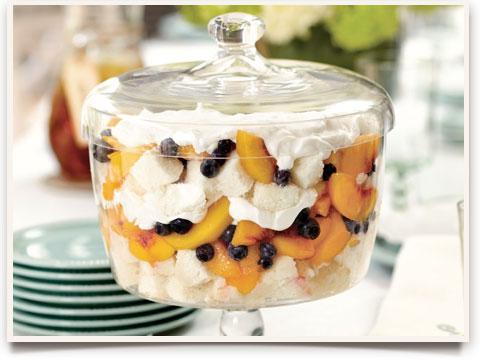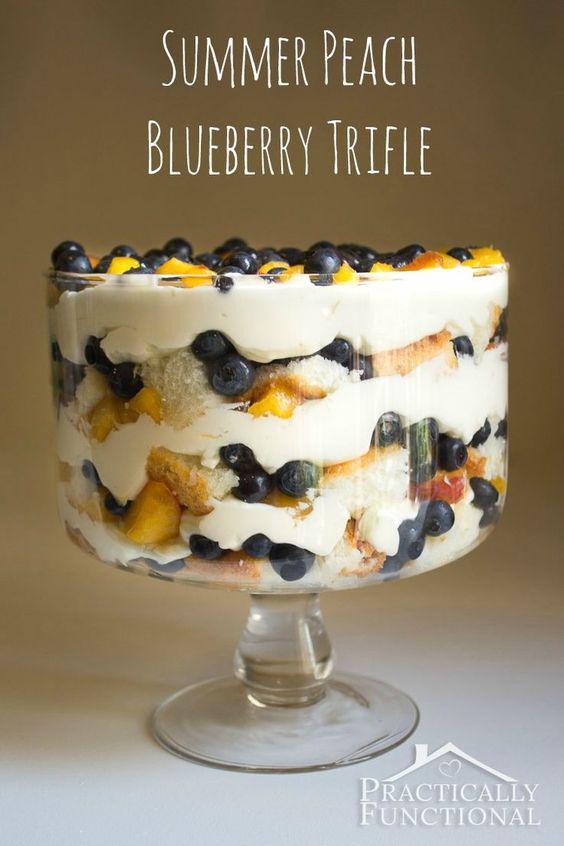The first image is the image on the left, the second image is the image on the right. Assess this claim about the two images: "One image in the pair contains a whole piece of fruit.". Correct or not? Answer yes or no. No. The first image is the image on the left, the second image is the image on the right. Examine the images to the left and right. Is the description "There are one or more spoons to the left of the truffle in one of the images." accurate? Answer yes or no. No. 